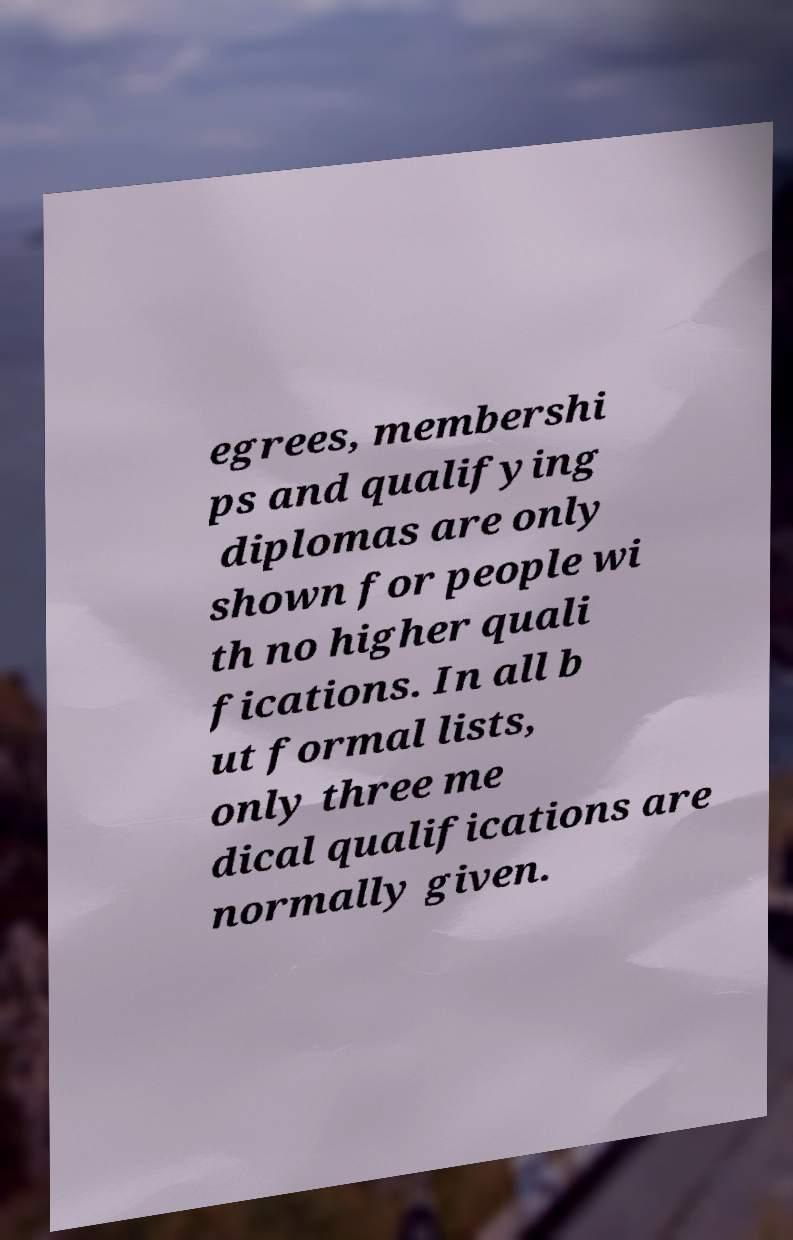For documentation purposes, I need the text within this image transcribed. Could you provide that? egrees, membershi ps and qualifying diplomas are only shown for people wi th no higher quali fications. In all b ut formal lists, only three me dical qualifications are normally given. 